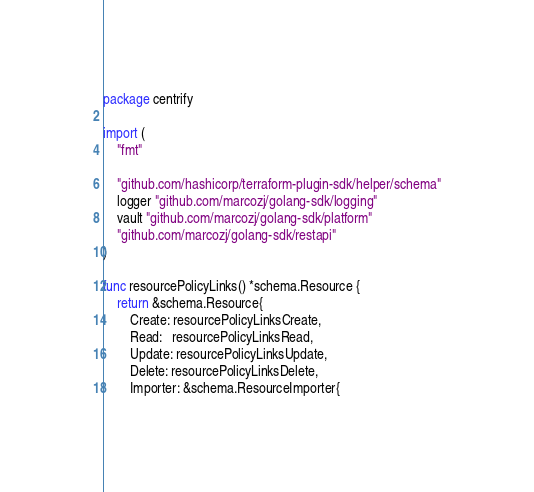Convert code to text. <code><loc_0><loc_0><loc_500><loc_500><_Go_>package centrify

import (
	"fmt"

	"github.com/hashicorp/terraform-plugin-sdk/helper/schema"
	logger "github.com/marcozj/golang-sdk/logging"
	vault "github.com/marcozj/golang-sdk/platform"
	"github.com/marcozj/golang-sdk/restapi"
)

func resourcePolicyLinks() *schema.Resource {
	return &schema.Resource{
		Create: resourcePolicyLinksCreate,
		Read:   resourcePolicyLinksRead,
		Update: resourcePolicyLinksUpdate,
		Delete: resourcePolicyLinksDelete,
		Importer: &schema.ResourceImporter{</code> 